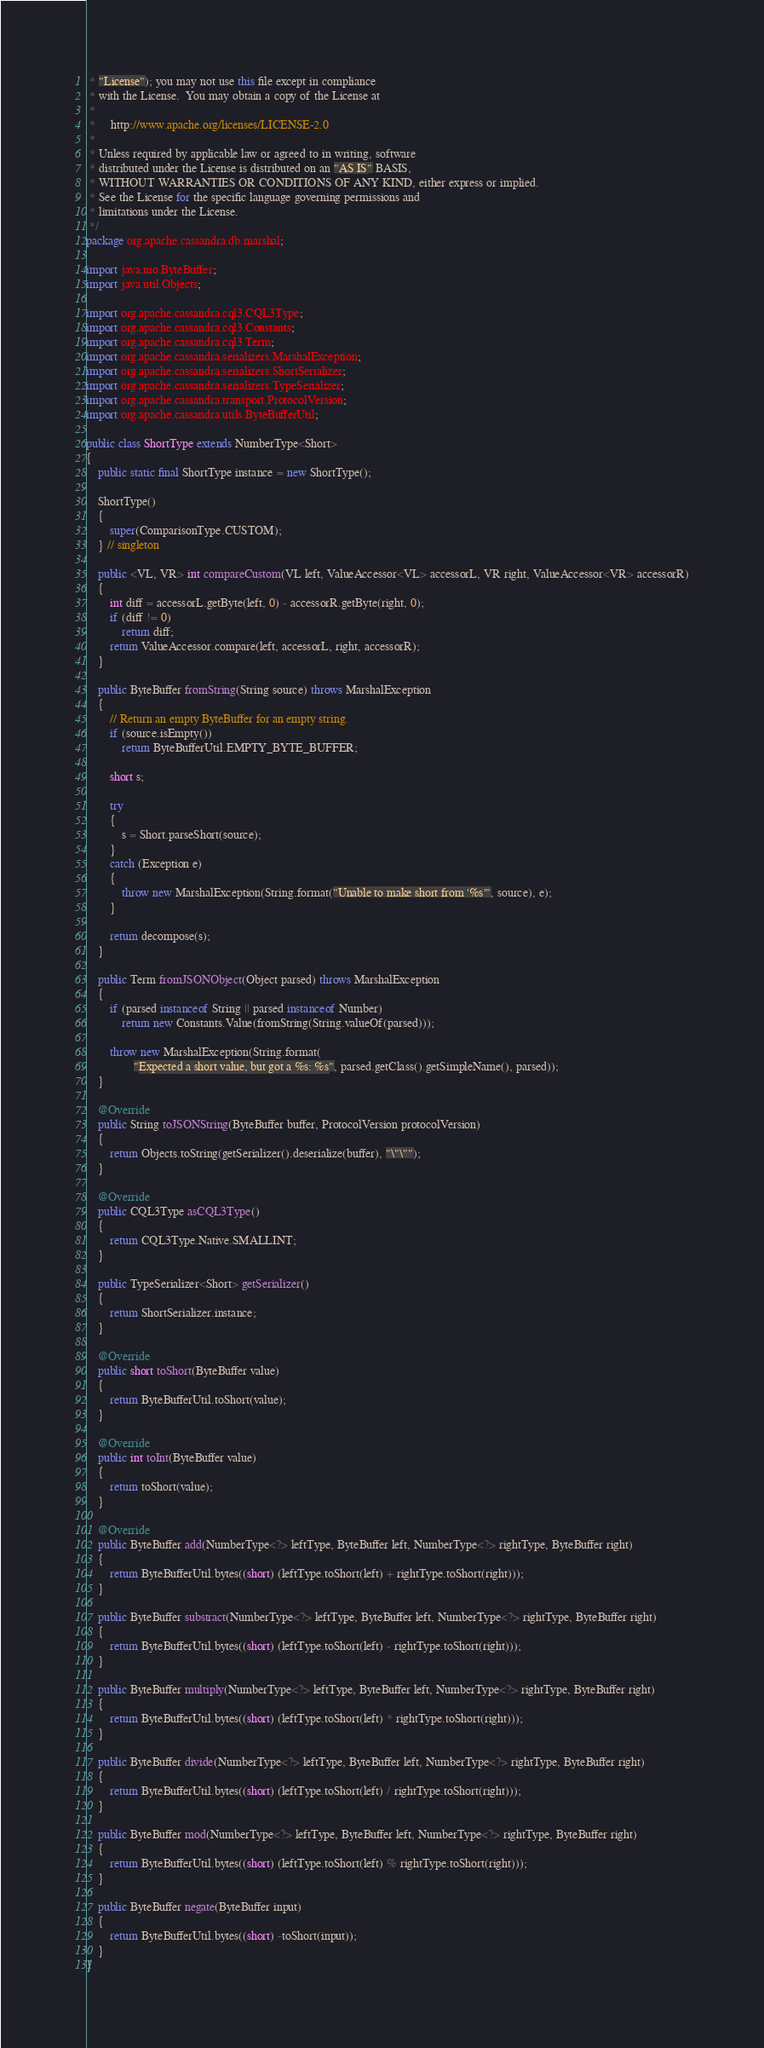<code> <loc_0><loc_0><loc_500><loc_500><_Java_> * "License"); you may not use this file except in compliance
 * with the License.  You may obtain a copy of the License at
 *
 *     http://www.apache.org/licenses/LICENSE-2.0
 *
 * Unless required by applicable law or agreed to in writing, software
 * distributed under the License is distributed on an "AS IS" BASIS,
 * WITHOUT WARRANTIES OR CONDITIONS OF ANY KIND, either express or implied.
 * See the License for the specific language governing permissions and
 * limitations under the License.
 */
package org.apache.cassandra.db.marshal;

import java.nio.ByteBuffer;
import java.util.Objects;

import org.apache.cassandra.cql3.CQL3Type;
import org.apache.cassandra.cql3.Constants;
import org.apache.cassandra.cql3.Term;
import org.apache.cassandra.serializers.MarshalException;
import org.apache.cassandra.serializers.ShortSerializer;
import org.apache.cassandra.serializers.TypeSerializer;
import org.apache.cassandra.transport.ProtocolVersion;
import org.apache.cassandra.utils.ByteBufferUtil;

public class ShortType extends NumberType<Short>
{
    public static final ShortType instance = new ShortType();

    ShortType()
    {
        super(ComparisonType.CUSTOM);
    } // singleton

    public <VL, VR> int compareCustom(VL left, ValueAccessor<VL> accessorL, VR right, ValueAccessor<VR> accessorR)
    {
        int diff = accessorL.getByte(left, 0) - accessorR.getByte(right, 0);
        if (diff != 0)
            return diff;
        return ValueAccessor.compare(left, accessorL, right, accessorR);
    }

    public ByteBuffer fromString(String source) throws MarshalException
    {
        // Return an empty ByteBuffer for an empty string.
        if (source.isEmpty())
            return ByteBufferUtil.EMPTY_BYTE_BUFFER;

        short s;

        try
        {
            s = Short.parseShort(source);
        }
        catch (Exception e)
        {
            throw new MarshalException(String.format("Unable to make short from '%s'", source), e);
        }

        return decompose(s);
    }

    public Term fromJSONObject(Object parsed) throws MarshalException
    {
        if (parsed instanceof String || parsed instanceof Number)
            return new Constants.Value(fromString(String.valueOf(parsed)));

        throw new MarshalException(String.format(
                "Expected a short value, but got a %s: %s", parsed.getClass().getSimpleName(), parsed));
    }

    @Override
    public String toJSONString(ByteBuffer buffer, ProtocolVersion protocolVersion)
    {
        return Objects.toString(getSerializer().deserialize(buffer), "\"\"");
    }

    @Override
    public CQL3Type asCQL3Type()
    {
        return CQL3Type.Native.SMALLINT;
    }

    public TypeSerializer<Short> getSerializer()
    {
        return ShortSerializer.instance;
    }

    @Override
    public short toShort(ByteBuffer value)
    {
        return ByteBufferUtil.toShort(value);
    }

    @Override
    public int toInt(ByteBuffer value)
    {
        return toShort(value);
    }

    @Override
    public ByteBuffer add(NumberType<?> leftType, ByteBuffer left, NumberType<?> rightType, ByteBuffer right)
    {
        return ByteBufferUtil.bytes((short) (leftType.toShort(left) + rightType.toShort(right)));
    }

    public ByteBuffer substract(NumberType<?> leftType, ByteBuffer left, NumberType<?> rightType, ByteBuffer right)
    {
        return ByteBufferUtil.bytes((short) (leftType.toShort(left) - rightType.toShort(right)));
    }

    public ByteBuffer multiply(NumberType<?> leftType, ByteBuffer left, NumberType<?> rightType, ByteBuffer right)
    {
        return ByteBufferUtil.bytes((short) (leftType.toShort(left) * rightType.toShort(right)));
    }

    public ByteBuffer divide(NumberType<?> leftType, ByteBuffer left, NumberType<?> rightType, ByteBuffer right)
    {
        return ByteBufferUtil.bytes((short) (leftType.toShort(left) / rightType.toShort(right)));
    }

    public ByteBuffer mod(NumberType<?> leftType, ByteBuffer left, NumberType<?> rightType, ByteBuffer right)
    {
        return ByteBufferUtil.bytes((short) (leftType.toShort(left) % rightType.toShort(right)));
    }

    public ByteBuffer negate(ByteBuffer input)
    {
        return ByteBufferUtil.bytes((short) -toShort(input));
    }
}
</code> 